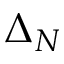<formula> <loc_0><loc_0><loc_500><loc_500>\Delta _ { N }</formula> 